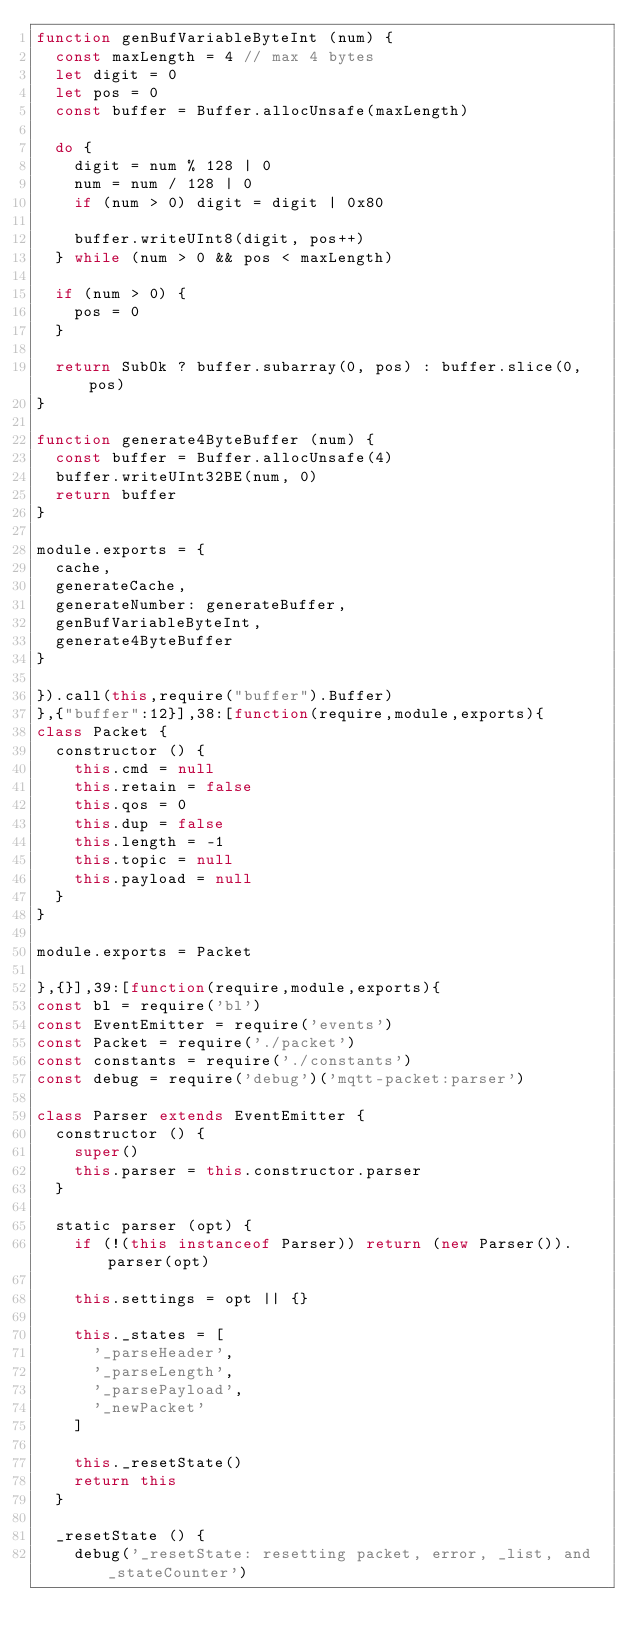<code> <loc_0><loc_0><loc_500><loc_500><_JavaScript_>function genBufVariableByteInt (num) {
  const maxLength = 4 // max 4 bytes
  let digit = 0
  let pos = 0
  const buffer = Buffer.allocUnsafe(maxLength)

  do {
    digit = num % 128 | 0
    num = num / 128 | 0
    if (num > 0) digit = digit | 0x80

    buffer.writeUInt8(digit, pos++)
  } while (num > 0 && pos < maxLength)

  if (num > 0) {
    pos = 0
  }

  return SubOk ? buffer.subarray(0, pos) : buffer.slice(0, pos)
}

function generate4ByteBuffer (num) {
  const buffer = Buffer.allocUnsafe(4)
  buffer.writeUInt32BE(num, 0)
  return buffer
}

module.exports = {
  cache,
  generateCache,
  generateNumber: generateBuffer,
  genBufVariableByteInt,
  generate4ByteBuffer
}

}).call(this,require("buffer").Buffer)
},{"buffer":12}],38:[function(require,module,exports){
class Packet {
  constructor () {
    this.cmd = null
    this.retain = false
    this.qos = 0
    this.dup = false
    this.length = -1
    this.topic = null
    this.payload = null
  }
}

module.exports = Packet

},{}],39:[function(require,module,exports){
const bl = require('bl')
const EventEmitter = require('events')
const Packet = require('./packet')
const constants = require('./constants')
const debug = require('debug')('mqtt-packet:parser')

class Parser extends EventEmitter {
  constructor () {
    super()
    this.parser = this.constructor.parser
  }

  static parser (opt) {
    if (!(this instanceof Parser)) return (new Parser()).parser(opt)

    this.settings = opt || {}

    this._states = [
      '_parseHeader',
      '_parseLength',
      '_parsePayload',
      '_newPacket'
    ]

    this._resetState()
    return this
  }

  _resetState () {
    debug('_resetState: resetting packet, error, _list, and _stateCounter')</code> 